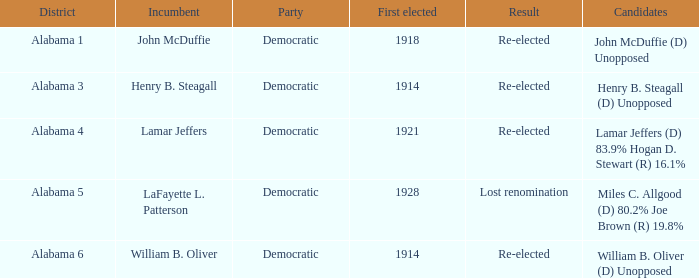How many in total were chosen first in lost renomination? 1.0. 